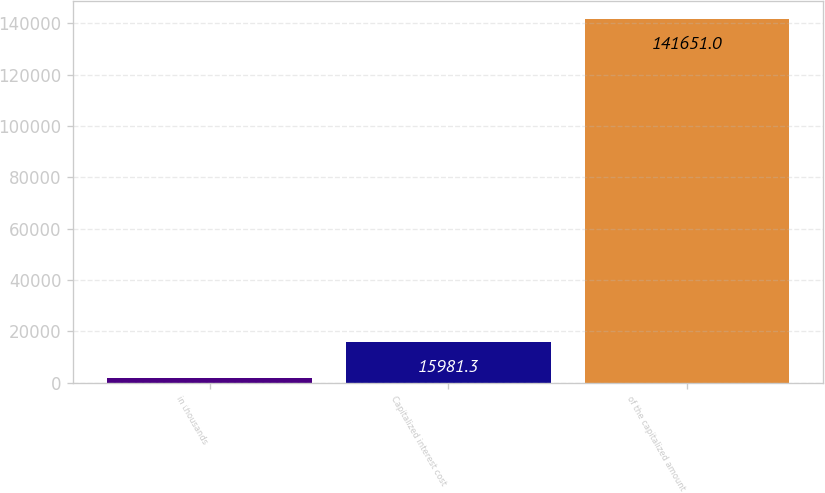<chart> <loc_0><loc_0><loc_500><loc_500><bar_chart><fcel>in thousands<fcel>Capitalized interest cost<fcel>of the capitalized amount<nl><fcel>2018<fcel>15981.3<fcel>141651<nl></chart> 